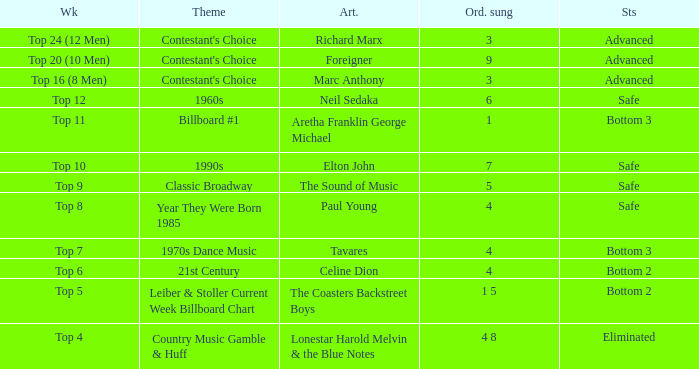What order was the performance of a Richard Marx song? 3.0. 